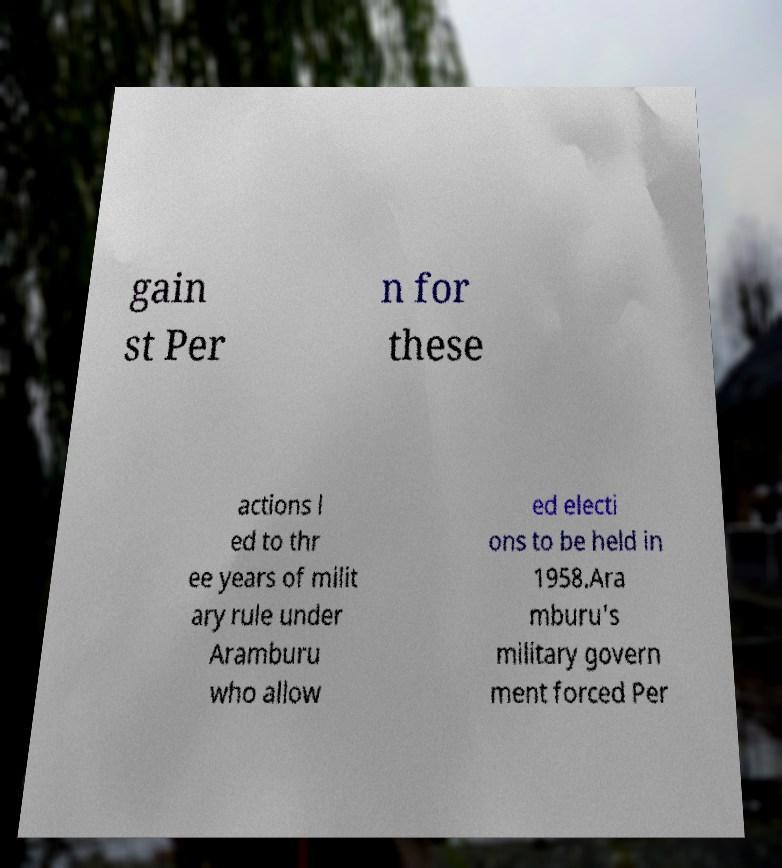Please identify and transcribe the text found in this image. gain st Per n for these actions l ed to thr ee years of milit ary rule under Aramburu who allow ed electi ons to be held in 1958.Ara mburu's military govern ment forced Per 